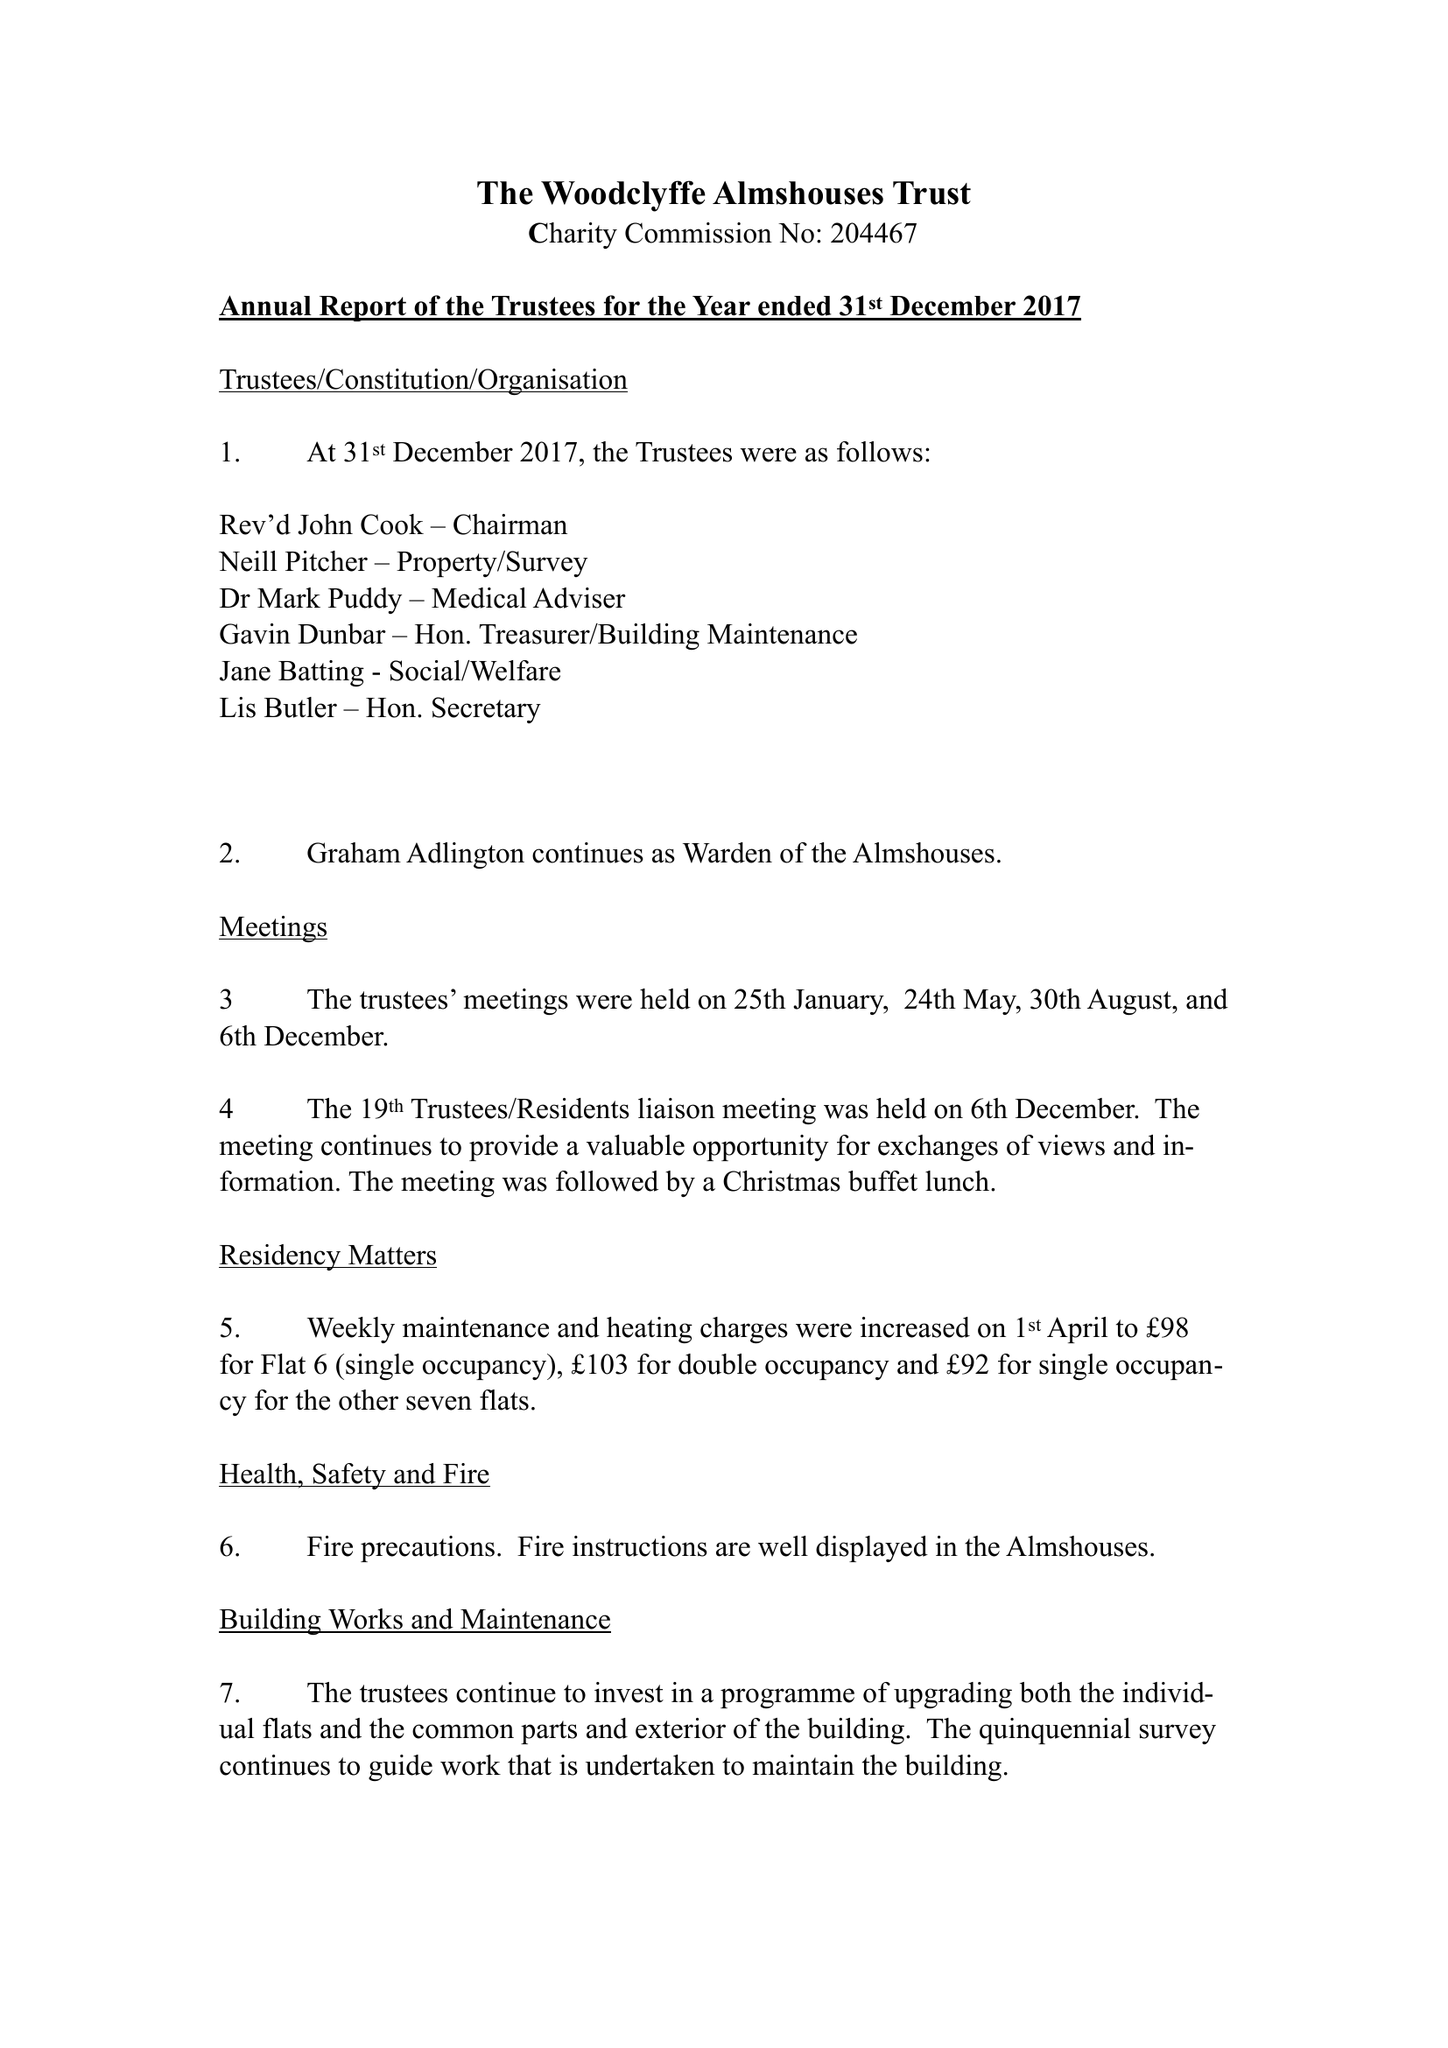What is the value for the charity_number?
Answer the question using a single word or phrase. 204467 